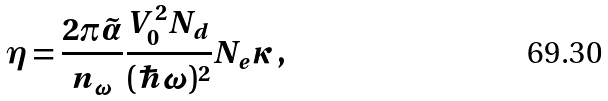Convert formula to latex. <formula><loc_0><loc_0><loc_500><loc_500>\eta = \frac { 2 \pi \tilde { \alpha } } { n _ { \omega } } \frac { V _ { 0 } ^ { 2 } N _ { d } } { ( \hbar { \omega } ) ^ { 2 } } N _ { e } \kappa \, ,</formula> 